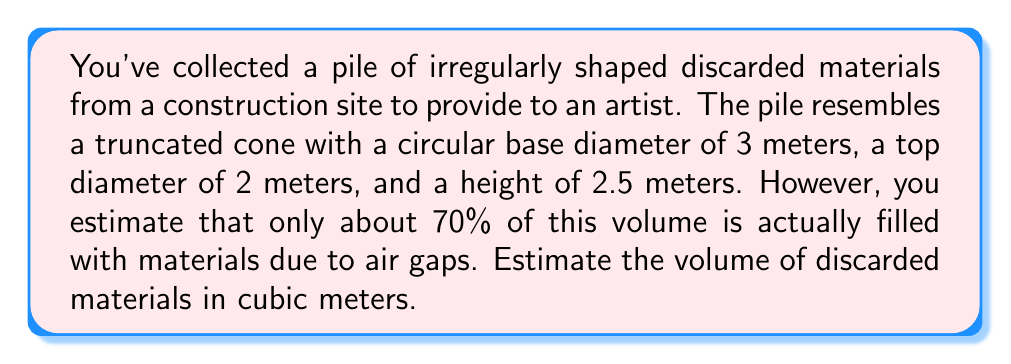Give your solution to this math problem. Let's approach this problem step-by-step:

1) First, we need to calculate the volume of the truncated cone. The formula for the volume of a truncated cone is:

   $$V = \frac{1}{3}\pi h(R^2 + r^2 + Rr)$$

   where $h$ is the height, $R$ is the radius of the base, and $r$ is the radius of the top.

2) We're given:
   $h = 2.5$ m
   Base diameter = 3 m, so $R = 1.5$ m
   Top diameter = 2 m, so $r = 1$ m

3) Let's substitute these values into the formula:

   $$V = \frac{1}{3}\pi \cdot 2.5(1.5^2 + 1^2 + 1.5 \cdot 1)$$

4) Simplify:
   $$V = \frac{1}{3}\pi \cdot 2.5(2.25 + 1 + 1.5)$$
   $$V = \frac{1}{3}\pi \cdot 2.5(4.75)$$
   $$V = \frac{1}{3}\pi \cdot 11.875$$
   $$V \approx 12.37 \text{ m}^3$$

5) However, this is the volume of the entire truncated cone. We're told that only about 70% of this volume is actually filled with materials due to air gaps.

6) To find the volume of the materials:
   $$V_{\text{materials}} = 12.37 \cdot 0.70 \approx 8.66 \text{ m}^3$$

Therefore, we estimate the volume of discarded materials to be approximately 8.66 cubic meters.
Answer: $8.66 \text{ m}^3$ 